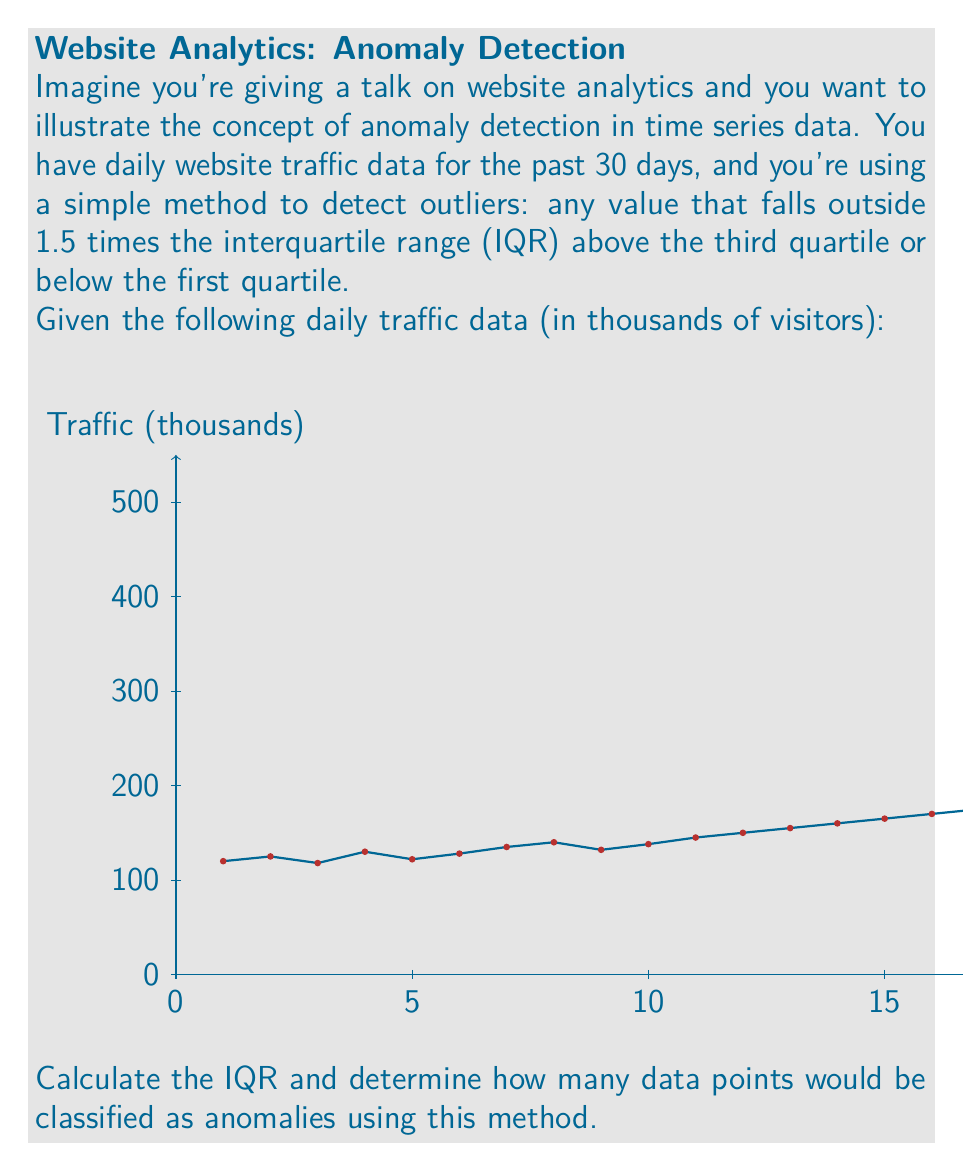Show me your answer to this math problem. Let's approach this step-by-step:

1) First, we need to calculate the quartiles. To do this, we'll sort the data and find the median, then the medians of the lower and upper halves.

   Sorted data: 118, 120, 122, 125, 128, 130, 132, 135, 138, 140, 145, 150, 155, 160, 165, 170, 175, 180, 185, 190, 195, 200, 205, 210, 215, 220, 225, 230, 235, 500

2) The median (Q2) is the average of the 15th and 16th terms: $Q2 = \frac{170 + 175}{2} = 172.5$

3) The first quartile (Q1) is the median of the lower half: $Q1 = 140$

4) The third quartile (Q3) is the median of the upper half: $Q3 = 210$

5) Now we can calculate the IQR: $IQR = Q3 - Q1 = 210 - 140 = 70$

6) We define outliers as any point below $Q1 - 1.5 * IQR$ or above $Q3 + 1.5 * IQR$:

   Lower bound: $140 - 1.5 * 70 = 35$
   Upper bound: $210 + 1.5 * 70 = 315$

7) Any data point below 35 or above 315 is considered an anomaly.

8) Looking at our data, we can see that only one point (500) is above the upper bound of 315.

Therefore, using this method, we would classify 1 data point as an anomaly.
Answer: 1 anomaly 